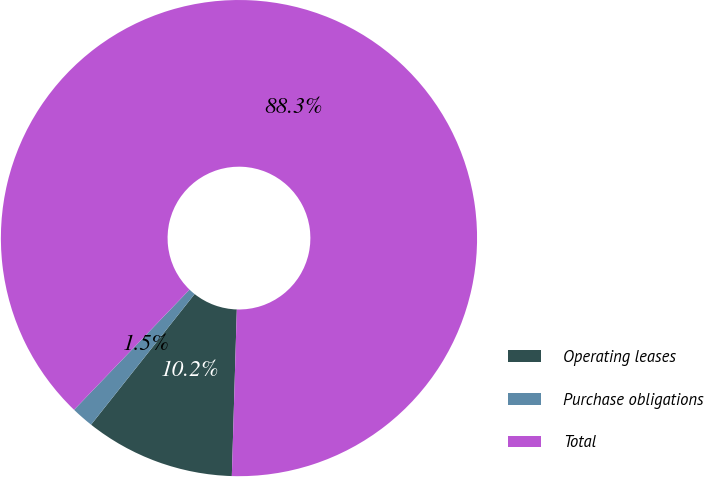<chart> <loc_0><loc_0><loc_500><loc_500><pie_chart><fcel>Operating leases<fcel>Purchase obligations<fcel>Total<nl><fcel>10.19%<fcel>1.51%<fcel>88.3%<nl></chart> 